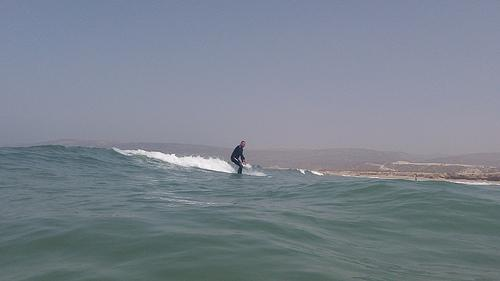What is the weather like in the image based on the sky? The weather seems calm with a clear, cloudless sky, and some haze. Examine the image and determine if the quality is high or low. The image quality is high with clear details and sharp focus. Can you identify at least three different landscape features in the image? Yes, there are mountains, shoreline, and ocean. What can you say about the clothing of the man in the image? The man is wearing a blue and black wetsuit while surfing. Count the number of natural elements present in the image. There are six natural elements: ocean, sky, mountains, shoreline, waves, and haze. Provide a brief summary of the scene within the image. A man in a blue and black wetsuit is surfing a small wave in the ocean with mountains, shoreline, and hazy sky in the background. Describe the color and state of the water in the image. The water is blue-green and wavy. What is the main activity taking place in the image? The main activity is a man surfing a small wave in the ocean. What is the sentiment evoked by the image? The image evokes a sense of tranquility, adventure, and connection with nature. Analyze if the man in the picture is interacting with any objects. The man is interacting with a surfboard and riding a wave in the ocean. 